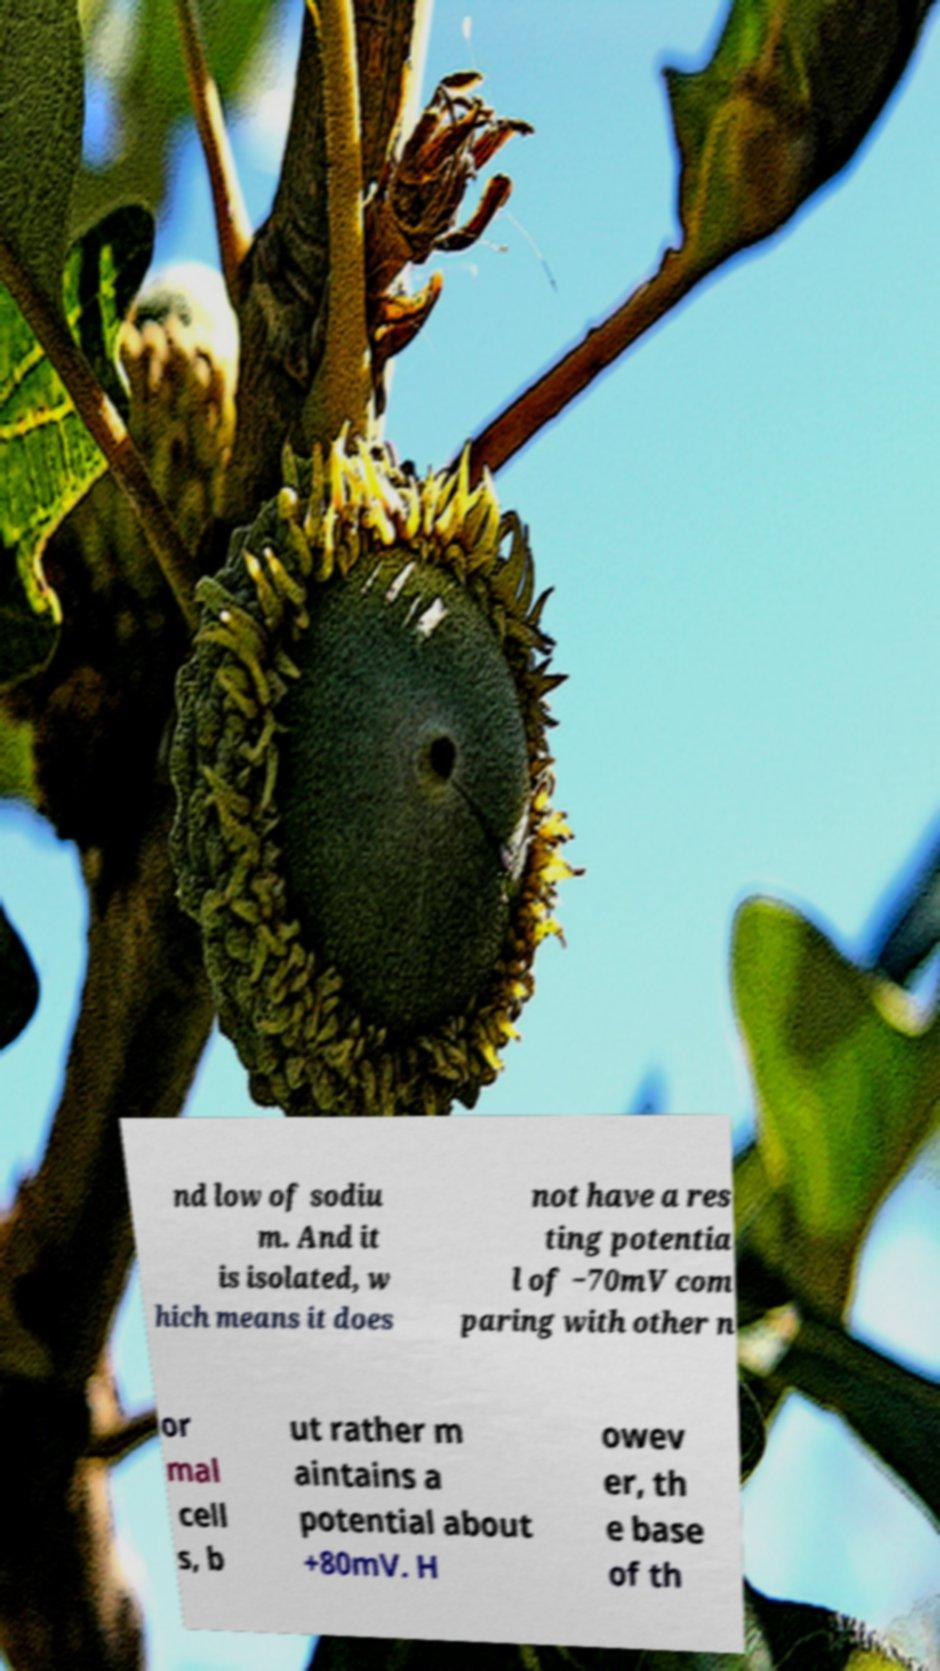There's text embedded in this image that I need extracted. Can you transcribe it verbatim? nd low of sodiu m. And it is isolated, w hich means it does not have a res ting potentia l of −70mV com paring with other n or mal cell s, b ut rather m aintains a potential about +80mV. H owev er, th e base of th 